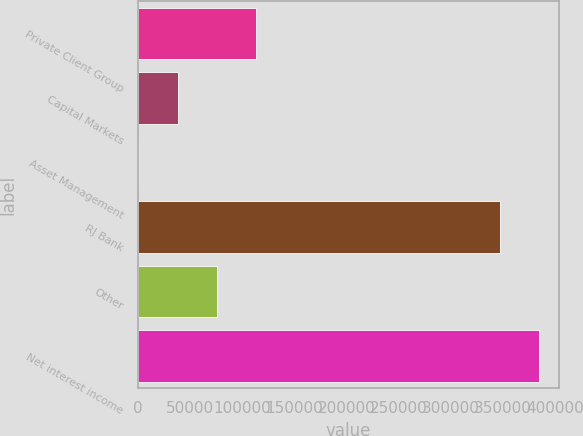<chart> <loc_0><loc_0><loc_500><loc_500><bar_chart><fcel>Private Client Group<fcel>Capital Markets<fcel>Asset Management<fcel>RJ Bank<fcel>Other<fcel>Net interest income<nl><fcel>113103<fcel>37762.3<fcel>92<fcel>346757<fcel>75432.6<fcel>384427<nl></chart> 